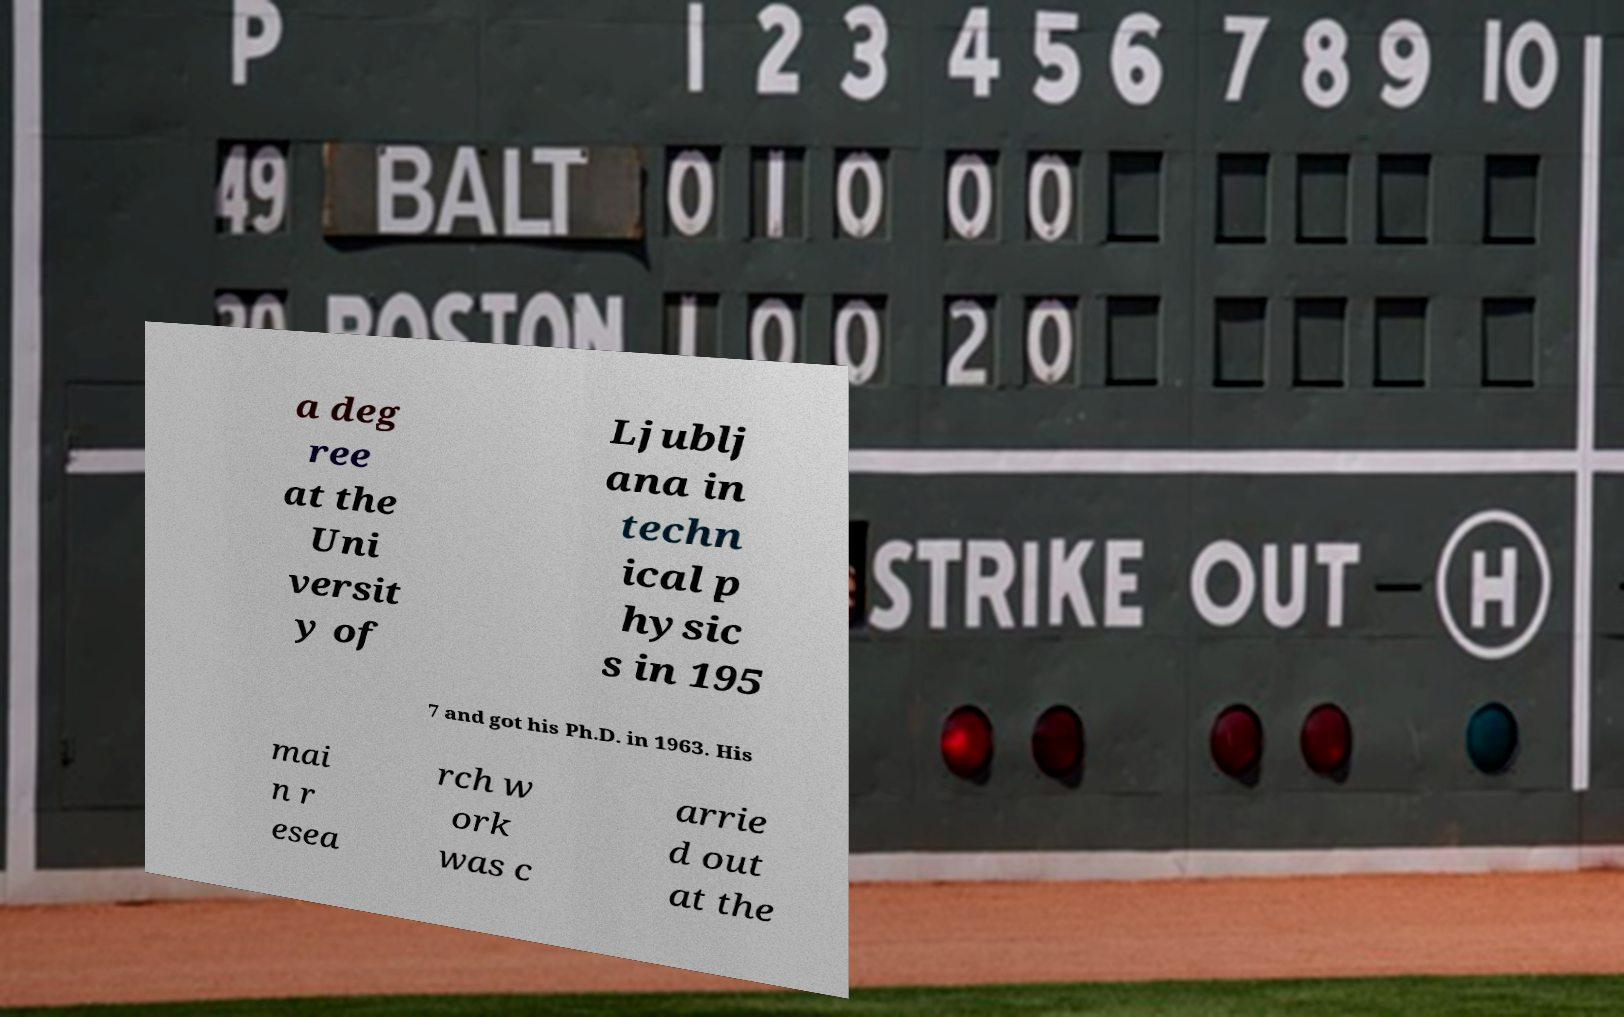For documentation purposes, I need the text within this image transcribed. Could you provide that? a deg ree at the Uni versit y of Ljublj ana in techn ical p hysic s in 195 7 and got his Ph.D. in 1963. His mai n r esea rch w ork was c arrie d out at the 